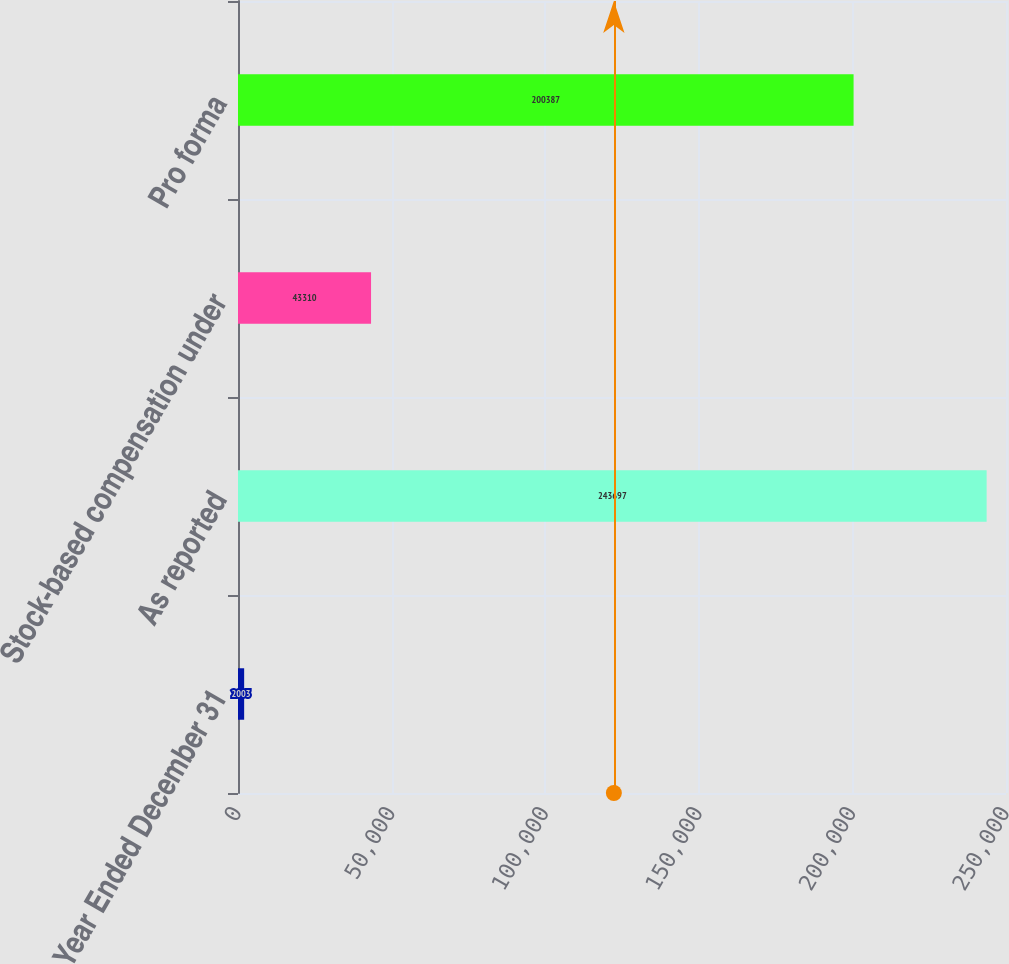Convert chart. <chart><loc_0><loc_0><loc_500><loc_500><bar_chart><fcel>Year Ended December 31<fcel>As reported<fcel>Stock-based compensation under<fcel>Pro forma<nl><fcel>2003<fcel>243697<fcel>43310<fcel>200387<nl></chart> 